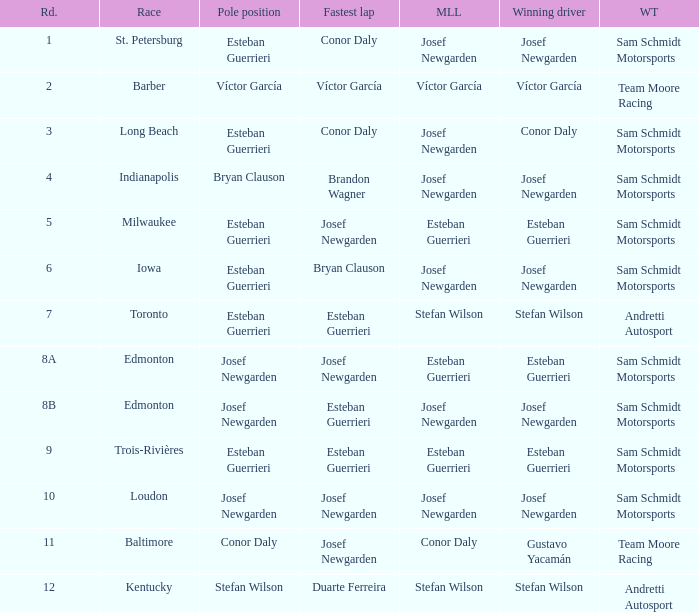What race did josef newgarden have the fastest lap and lead the most laps? Loudon. 